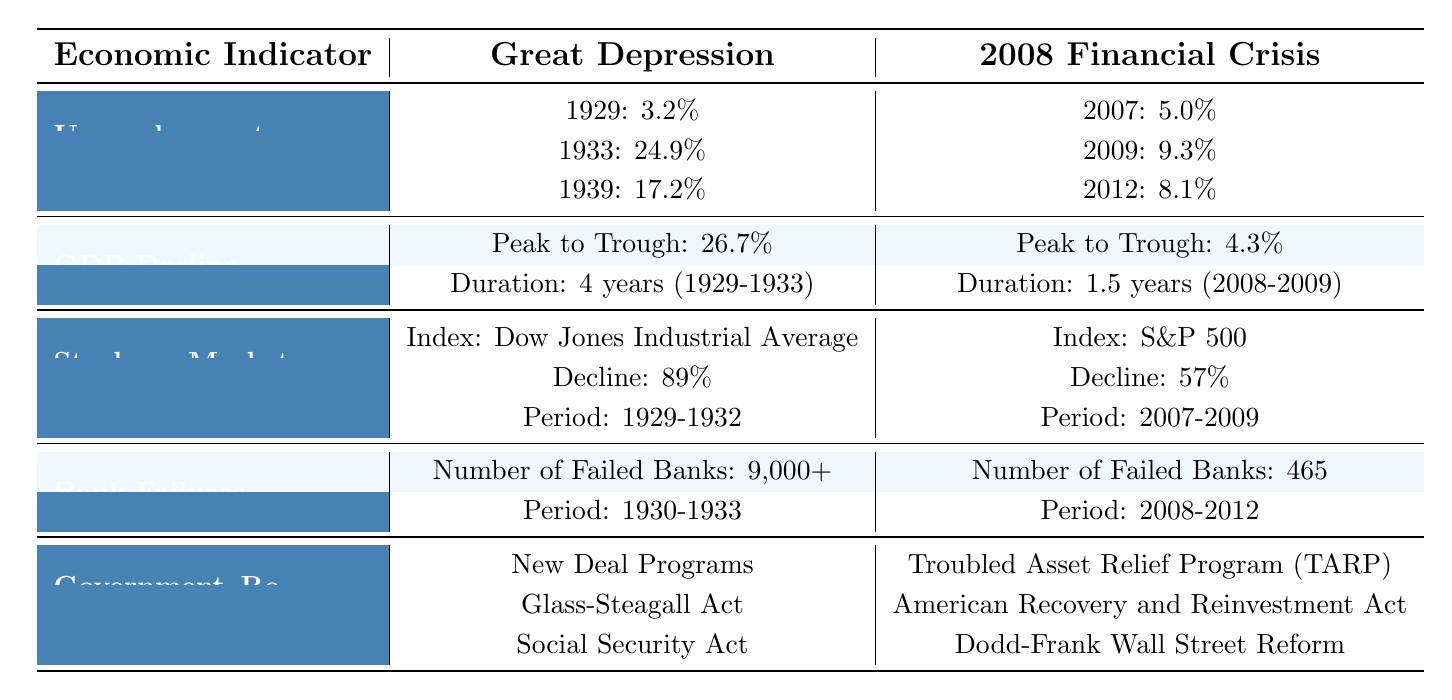What was the unemployment rate in 1933 during the Great Depression? The table lists the unemployment rates for various years. In the Great Depression, the unemployment rate for 1933 is specifically stated as 24.9%.
Answer: 24.9% How much did GDP decline during the Great Depression compared to the 2008 Financial Crisis? The table shows the GDP decline as 26.7% for the Great Depression and 4.3% for the 2008 Financial Crisis. The difference is calculated as 26.7% - 4.3% = 22.4%.
Answer: 22.4% Was the stock market decline during the Great Depression greater than during the 2008 Financial Crisis? The table shows that the stock market declined by 89% during the Great Depression and 57% during the 2008 Financial Crisis. Since 89% is greater than 57%, this statement is true.
Answer: Yes What was the total number of bank failures during the Great Depression compared to the 2008 Financial Crisis? The table states that there were over 9,000 bank failures during the Great Depression and 465 during the 2008 Financial Crisis. To find the total, you would need to combine these figures: 9,000 + 465 = 9,465 (noting over 9,000 is approximate).
Answer: 9,465 Which economic indicator reflects a longer duration of decline, GDP during the Great Depression or the 2008 Financial Crisis? The table specifies that the duration of GDP decline during the Great Depression was 4 years (1929-1933), while the duration during the 2008 Financial Crisis was 1.5 years (2008-2009). Therefore, 4 years is longer than 1.5 years.
Answer: Great Depression What specific actions did the government take during the 2008 Financial Crisis compared to the Great Depression? The table lists government responses for both crises. For the Great Depression, the actions included New Deal Programs, Glass-Steagall Act, and Social Security Act. For the 2008 Financial Crisis, actions included Troubled Asset Relief Program (TARP), American Recovery and Reinvestment Act, and Dodd-Frank Wall Street Reform.
Answer: Different programs What was the average unemployment rate for the Great Depression listed in the table? The table provides three unemployment rates for the Great Depression: 3.2% (1929), 24.9% (1933), and 17.2% (1939). To calculate the average: (3.2 + 24.9 + 17.2) / 3 = 15.1%.
Answer: 15.1% Which economic downturn saw a more significant percentage of bank failures relative to the overall number of banks operating at the time? While the table provides specific numbers of bank failures for both periods, it does not contain the total number of banks at the respective times, which is necessary for this calculation. Hence, we cannot determine this ratio solely from the table.
Answer: Data insufficient What was the duration of the stock market crash during the Great Depression? The table indicates that the stock market crash during the Great Depression lasted from 1929 to 1932, which totals 3 years.
Answer: 3 years Did the government implement the Glass-Steagall Act during the 2008 Financial Crisis? According to the table, the Glass-Steagall Act is listed under government responses for the Great Depression, and it is not mentioned for the 2008 Financial Crisis. Therefore, the government did not implement it during the latter.
Answer: No 